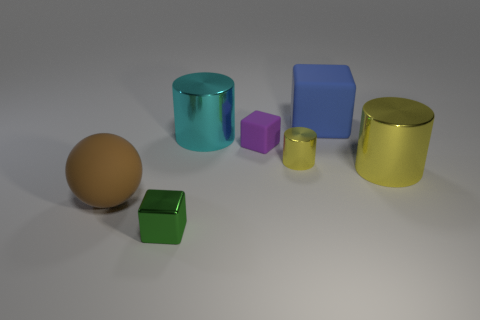If we were to arrange these objects by size, starting with the smallest, how would that order look? Starting with the smallest, the order would likely be the small yellow rubber object, the purple cube, the green cube, the brown rubber object, the blue cube, the cyan cylinder, and finally the golden cylinder as the largest object visible. 